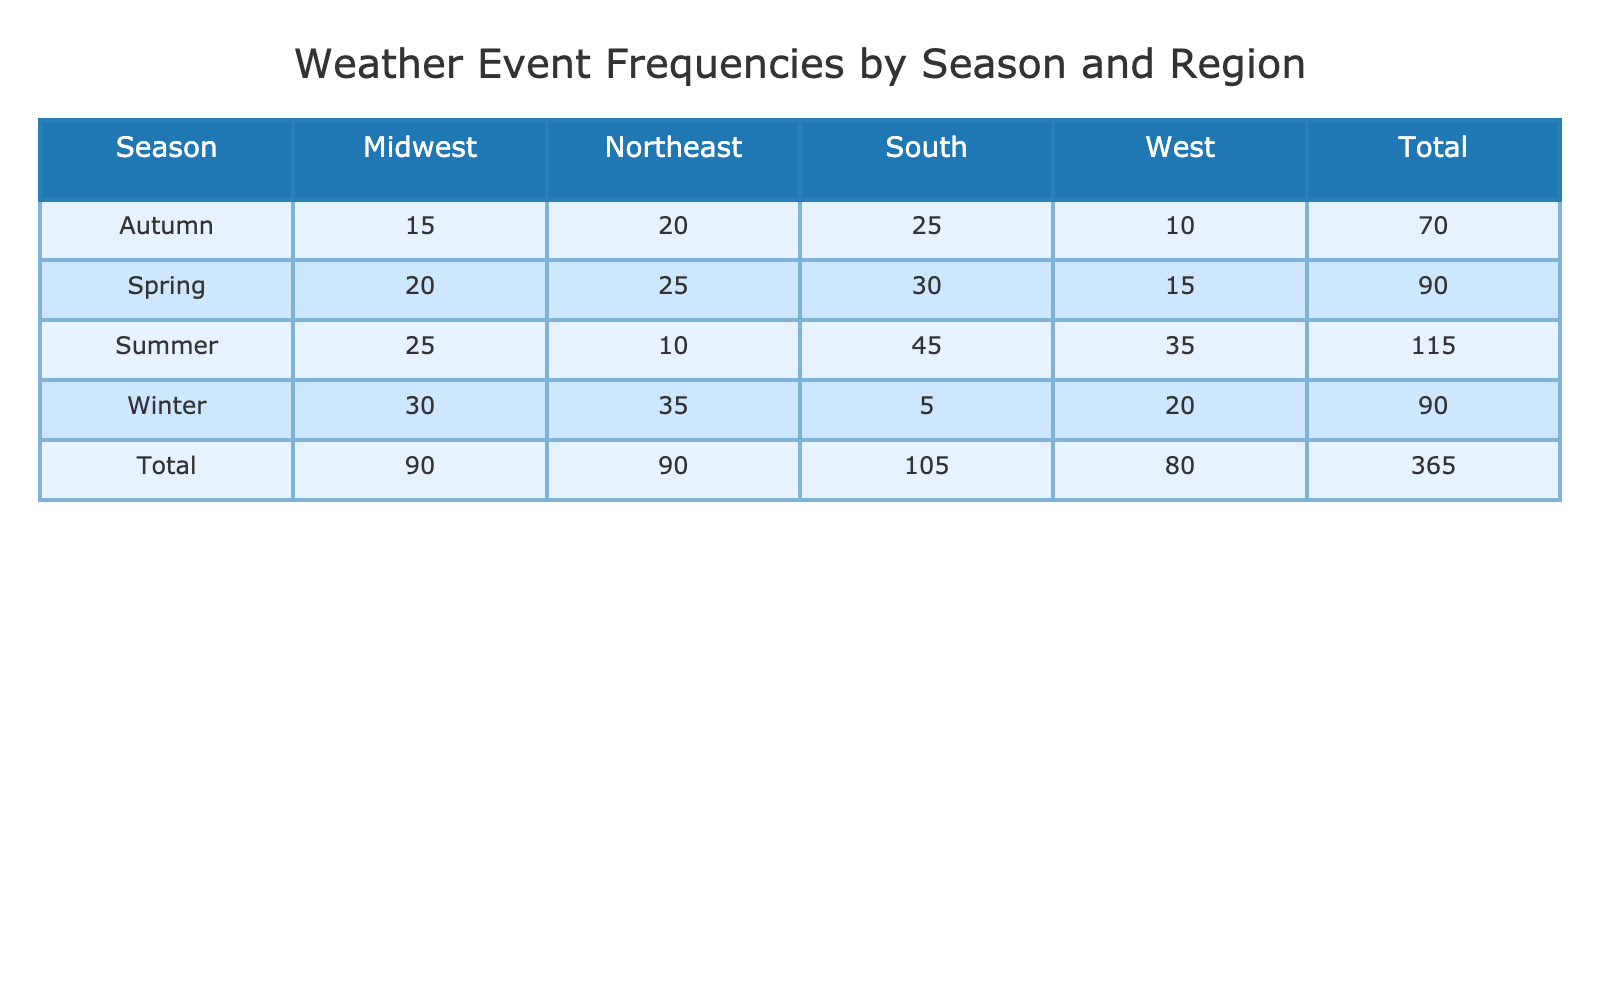What is the weather event frequency in the South during Summer? According to the table, the frequency for the South in Summer is listed directly under that column as 45.
Answer: 45 What is the total weather event frequency for the Northeast region across all seasons? By summing the values in the Northeast column (25 in Spring, 10 in Summer, 20 in Autumn, and 35 in Winter), we calculate 25 + 10 + 20 + 35 = 90.
Answer: 90 Is the weather event frequency in Winter higher in the Midwest or West? In Winter, the Midwest has a frequency of 30 and the West has a frequency of 20. Since 30 > 20, the Midwest has a higher frequency.
Answer: Yes What is the average weather event frequency for the West region across all seasons? The frequencies for the West are 15 (Spring), 35 (Summer), 10 (Autumn), and 20 (Winter). We sum these values: 15 + 35 + 10 + 20 = 80. There are 4 seasons, so the average is 80 / 4 = 20.
Answer: 20 Which season has the highest total weather event frequency when summing across all regions? We need to calculate the total frequency for each season: Spring (25 + 30 + 20 + 15 = 90), Summer (10 + 45 + 25 + 35 = 115), Autumn (20 + 25 + 15 + 10 = 70), Winter (35 + 5 + 30 + 20 = 90). The highest total is 115 in Summer.
Answer: Summer How does the weather event frequency for Autumn in the South compare to Winter in the Northeast? The Autumn frequency in the South is 25, and the Winter frequency in the Northeast is 35. Since 25 < 35, Winter in the Northeast is higher.
Answer: No What is the difference in weather event frequency between Spring and Winter in the South? The South's frequency in Spring is 30, while in Winter it is 5. Calculating the difference: 30 - 5 = 25.
Answer: 25 What is the total weather event frequency for the Midwest across all seasons? The frequencies for the Midwest are 20 (Spring), 25 (Summer), 15 (Autumn), and 30 (Winter). Summing these: 20 + 25 + 15 + 30 = 90.
Answer: 90 Is the total weather event frequency in the West region across all seasons greater than that in the Northeast? For West, the sum is 15 (Spring) + 35 (Summer) + 10 (Autumn) + 20 (Winter) = 80. For Northeast, the sum is 90. Since 80 < 90, it is not greater.
Answer: No 